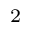Convert formula to latex. <formula><loc_0><loc_0><loc_500><loc_500>_ { 2 }</formula> 